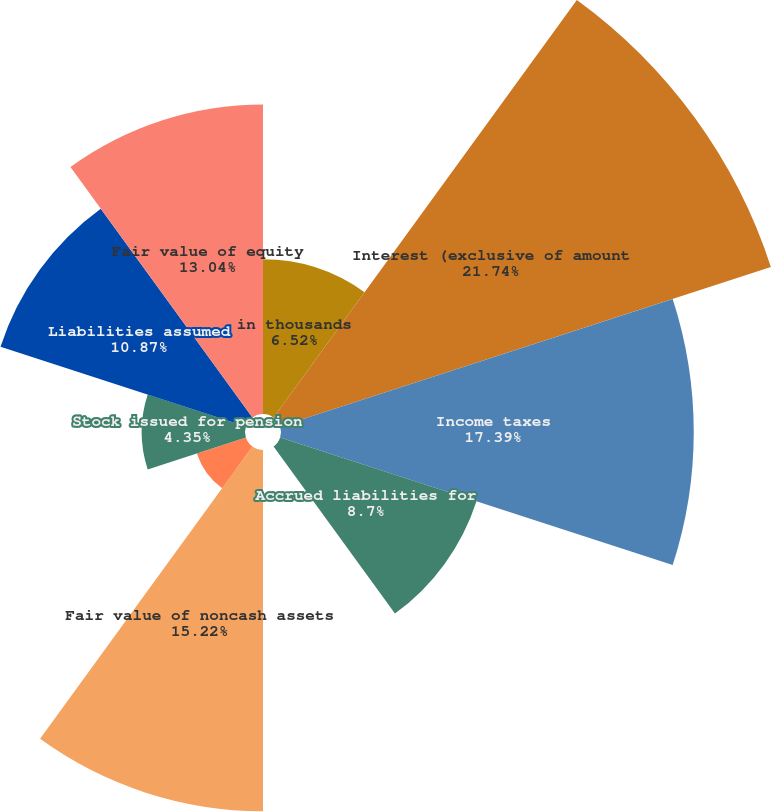<chart> <loc_0><loc_0><loc_500><loc_500><pie_chart><fcel>in thousands<fcel>Interest (exclusive of amount<fcel>Income taxes<fcel>Accrued liabilities for<fcel>Note received from sale of<fcel>Fair value of noncash assets<fcel>Debt issued for purchases of<fcel>Stock issued for pension<fcel>Liabilities assumed<fcel>Fair value of equity<nl><fcel>6.52%<fcel>21.74%<fcel>17.39%<fcel>8.7%<fcel>0.0%<fcel>15.22%<fcel>2.17%<fcel>4.35%<fcel>10.87%<fcel>13.04%<nl></chart> 